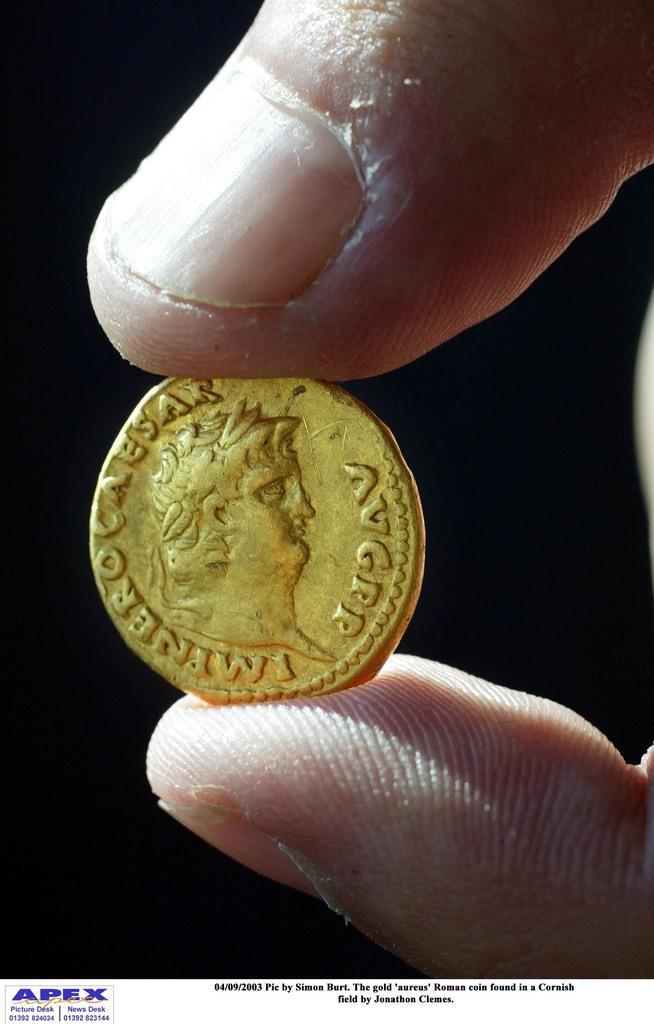Can you describe this image briefly? In this picture I can see the figures of a person holding a coin. 